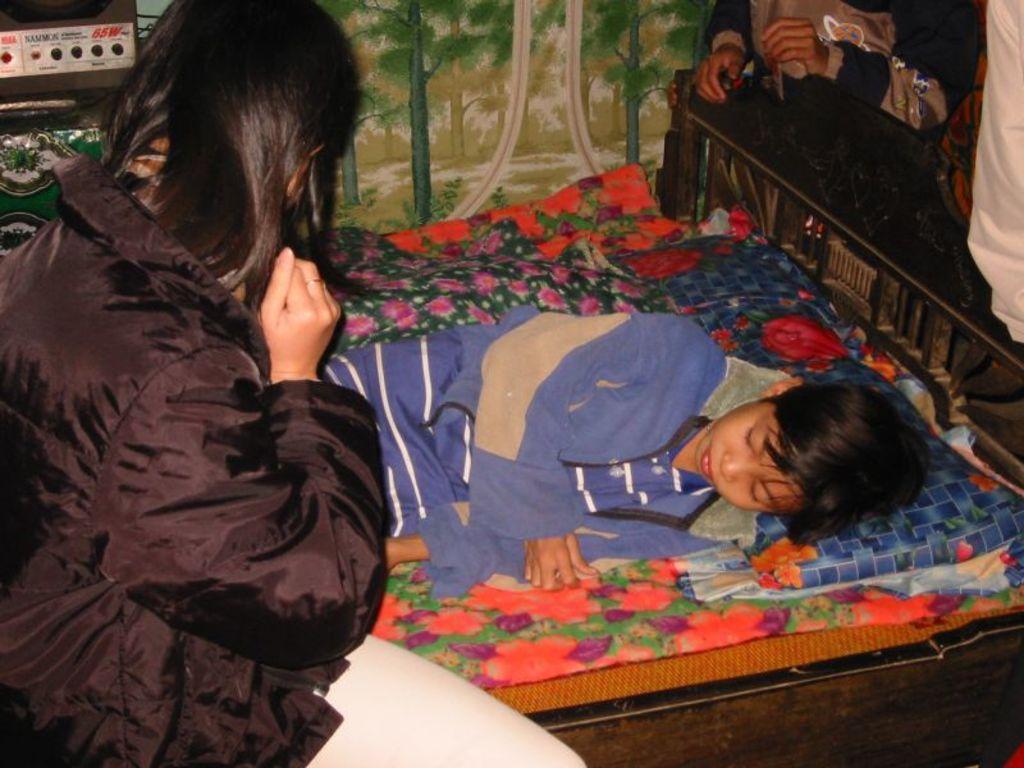In one or two sentences, can you explain what this image depicts? In this image, in the left side there is a girl sitting on a bed, in the middle there is a kid sitting on the bed which is in black color, in the background there is a green color cloth, there are some people standing around the bed. 